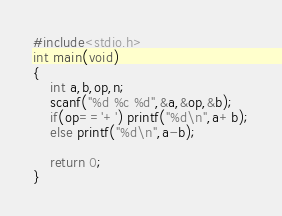<code> <loc_0><loc_0><loc_500><loc_500><_C_>#include<stdio.h>
int main(void)
{
	int a,b,op,n;
	scanf("%d %c %d",&a,&op,&b);
	if(op=='+') printf("%d\n",a+b);
	else printf("%d\n",a-b);
	
	return 0;
}
</code> 